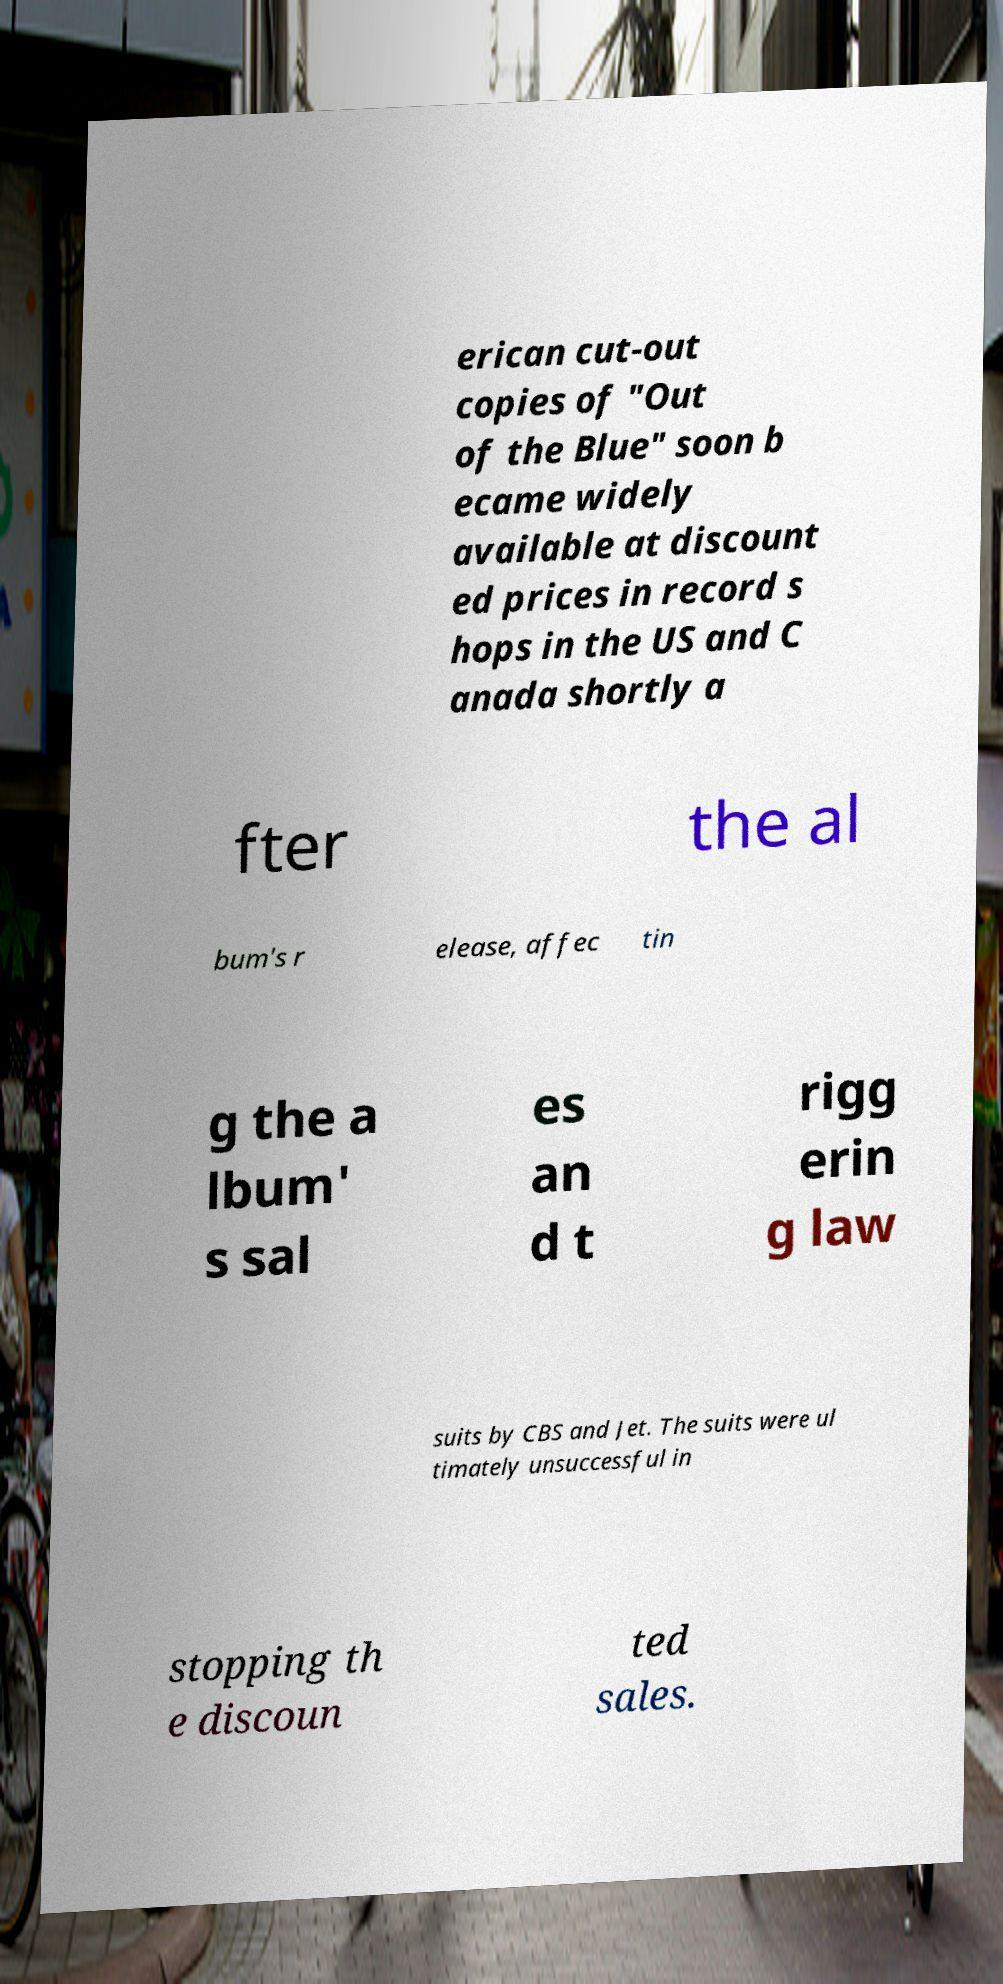Please identify and transcribe the text found in this image. erican cut-out copies of "Out of the Blue" soon b ecame widely available at discount ed prices in record s hops in the US and C anada shortly a fter the al bum's r elease, affec tin g the a lbum' s sal es an d t rigg erin g law suits by CBS and Jet. The suits were ul timately unsuccessful in stopping th e discoun ted sales. 